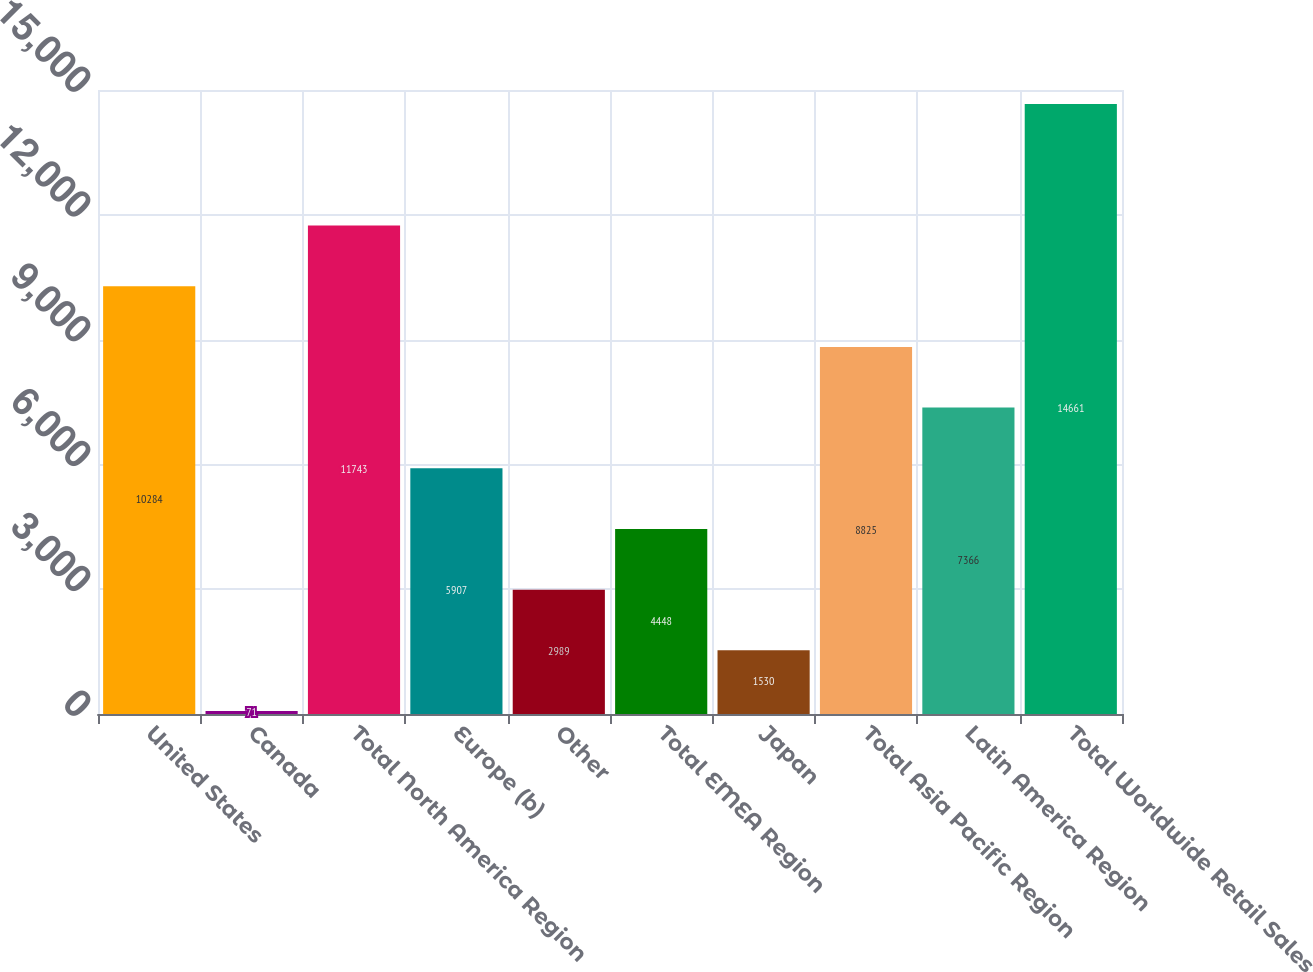Convert chart to OTSL. <chart><loc_0><loc_0><loc_500><loc_500><bar_chart><fcel>United States<fcel>Canada<fcel>Total North America Region<fcel>Europe (b)<fcel>Other<fcel>Total EMEA Region<fcel>Japan<fcel>Total Asia Pacific Region<fcel>Latin America Region<fcel>Total Worldwide Retail Sales<nl><fcel>10284<fcel>71<fcel>11743<fcel>5907<fcel>2989<fcel>4448<fcel>1530<fcel>8825<fcel>7366<fcel>14661<nl></chart> 